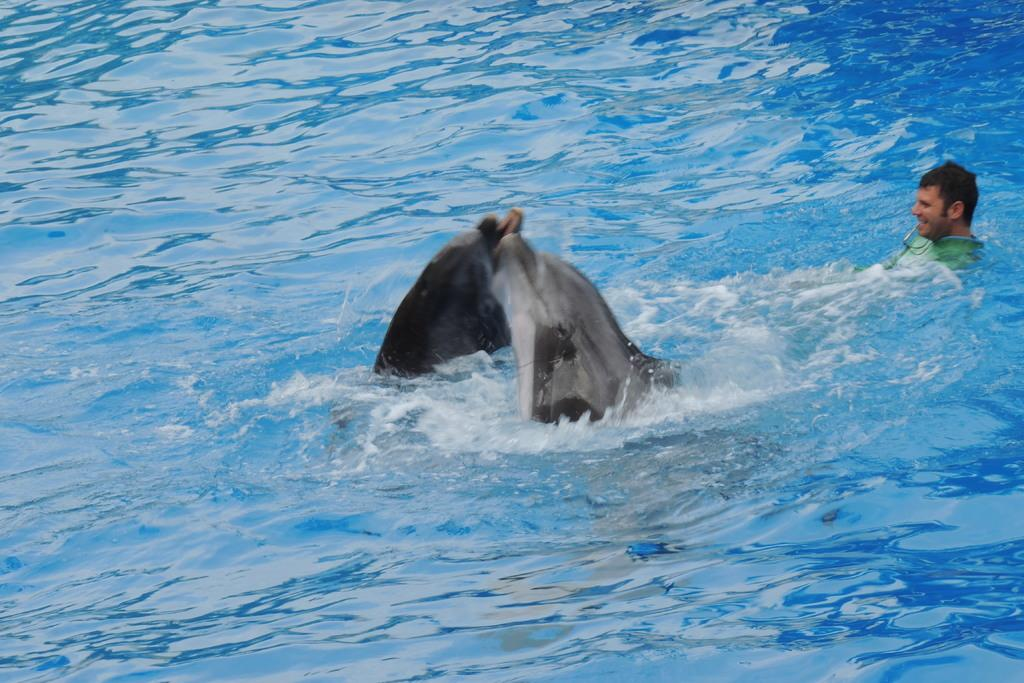Who or what is present in the image? There is a person in the image. What is the person doing? The person is in the water. What else can be seen in the image? There are ships in the image. What type of rat can be seen in the image? There is no rat present in the image. 